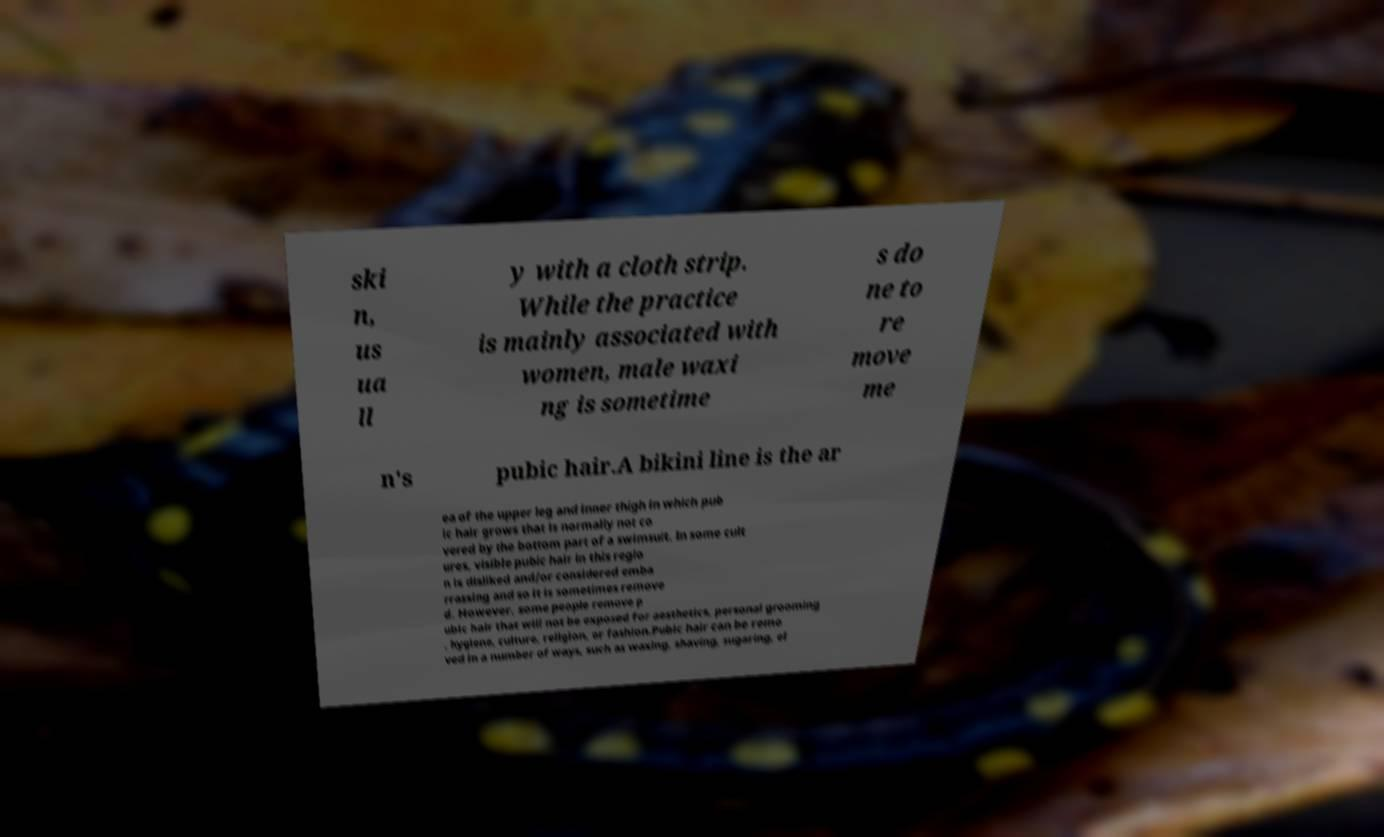Can you read and provide the text displayed in the image?This photo seems to have some interesting text. Can you extract and type it out for me? ski n, us ua ll y with a cloth strip. While the practice is mainly associated with women, male waxi ng is sometime s do ne to re move me n's pubic hair.A bikini line is the ar ea of the upper leg and inner thigh in which pub ic hair grows that is normally not co vered by the bottom part of a swimsuit. In some cult ures, visible pubic hair in this regio n is disliked and/or considered emba rrassing and so it is sometimes remove d. However, some people remove p ubic hair that will not be exposed for aesthetics, personal grooming , hygiene, culture, religion, or fashion.Pubic hair can be remo ved in a number of ways, such as waxing, shaving, sugaring, el 